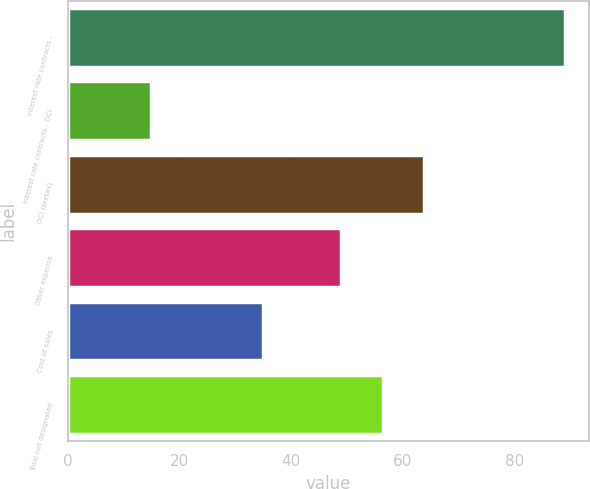Convert chart to OTSL. <chart><loc_0><loc_0><loc_500><loc_500><bar_chart><fcel>Interest rate contracts -<fcel>Interest rate contracts - OCI<fcel>OCI (pretax)<fcel>Other expense<fcel>Cost of sales<fcel>Total not designated<nl><fcel>89<fcel>15<fcel>63.8<fcel>49<fcel>35<fcel>56.4<nl></chart> 